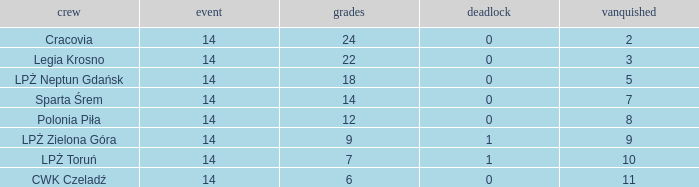What is the sum for the match with a draw less than 0? None. 